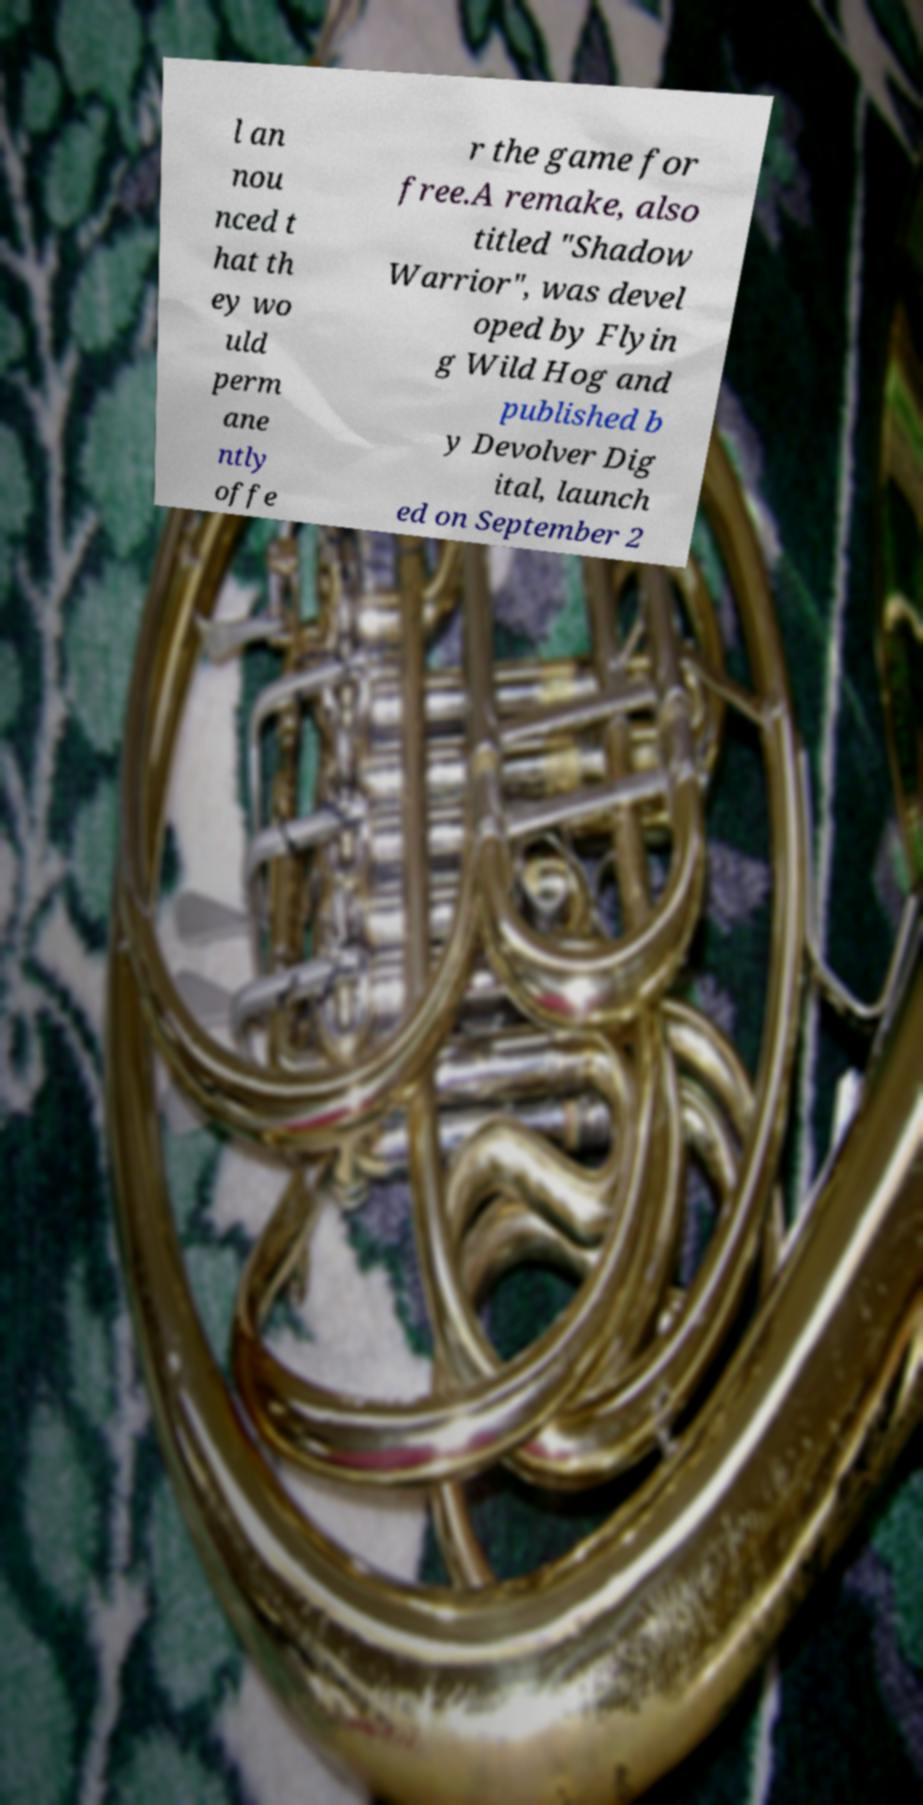What messages or text are displayed in this image? I need them in a readable, typed format. l an nou nced t hat th ey wo uld perm ane ntly offe r the game for free.A remake, also titled "Shadow Warrior", was devel oped by Flyin g Wild Hog and published b y Devolver Dig ital, launch ed on September 2 